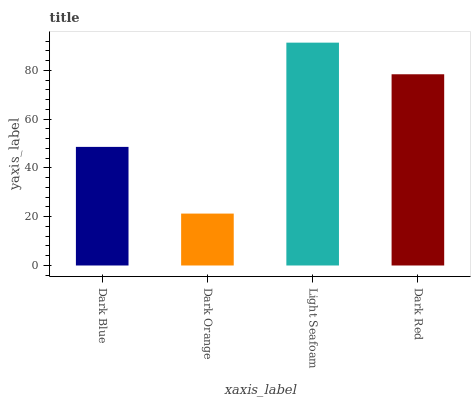Is Dark Orange the minimum?
Answer yes or no. Yes. Is Light Seafoam the maximum?
Answer yes or no. Yes. Is Light Seafoam the minimum?
Answer yes or no. No. Is Dark Orange the maximum?
Answer yes or no. No. Is Light Seafoam greater than Dark Orange?
Answer yes or no. Yes. Is Dark Orange less than Light Seafoam?
Answer yes or no. Yes. Is Dark Orange greater than Light Seafoam?
Answer yes or no. No. Is Light Seafoam less than Dark Orange?
Answer yes or no. No. Is Dark Red the high median?
Answer yes or no. Yes. Is Dark Blue the low median?
Answer yes or no. Yes. Is Light Seafoam the high median?
Answer yes or no. No. Is Light Seafoam the low median?
Answer yes or no. No. 